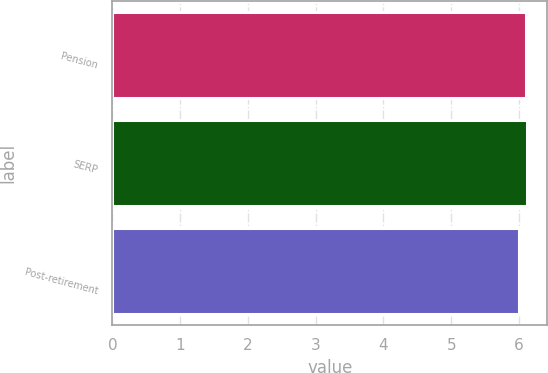Convert chart. <chart><loc_0><loc_0><loc_500><loc_500><bar_chart><fcel>Pension<fcel>SERP<fcel>Post-retirement<nl><fcel>6.1<fcel>6.11<fcel>6<nl></chart> 